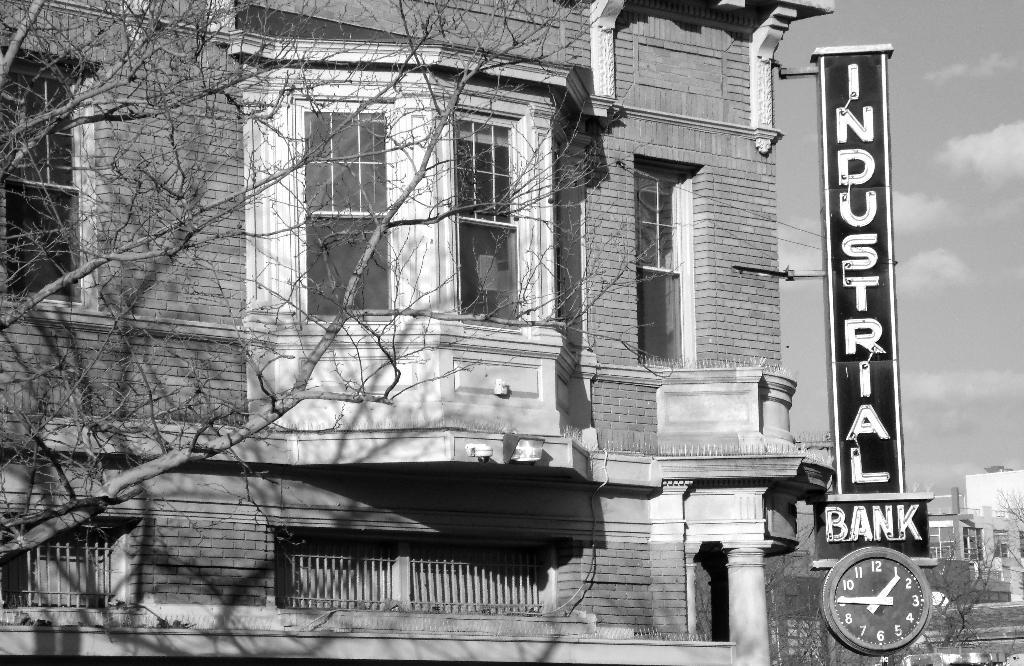<image>
Relay a brief, clear account of the picture shown. The Industrial Bank outdoor clock shows the time of 1:45. 